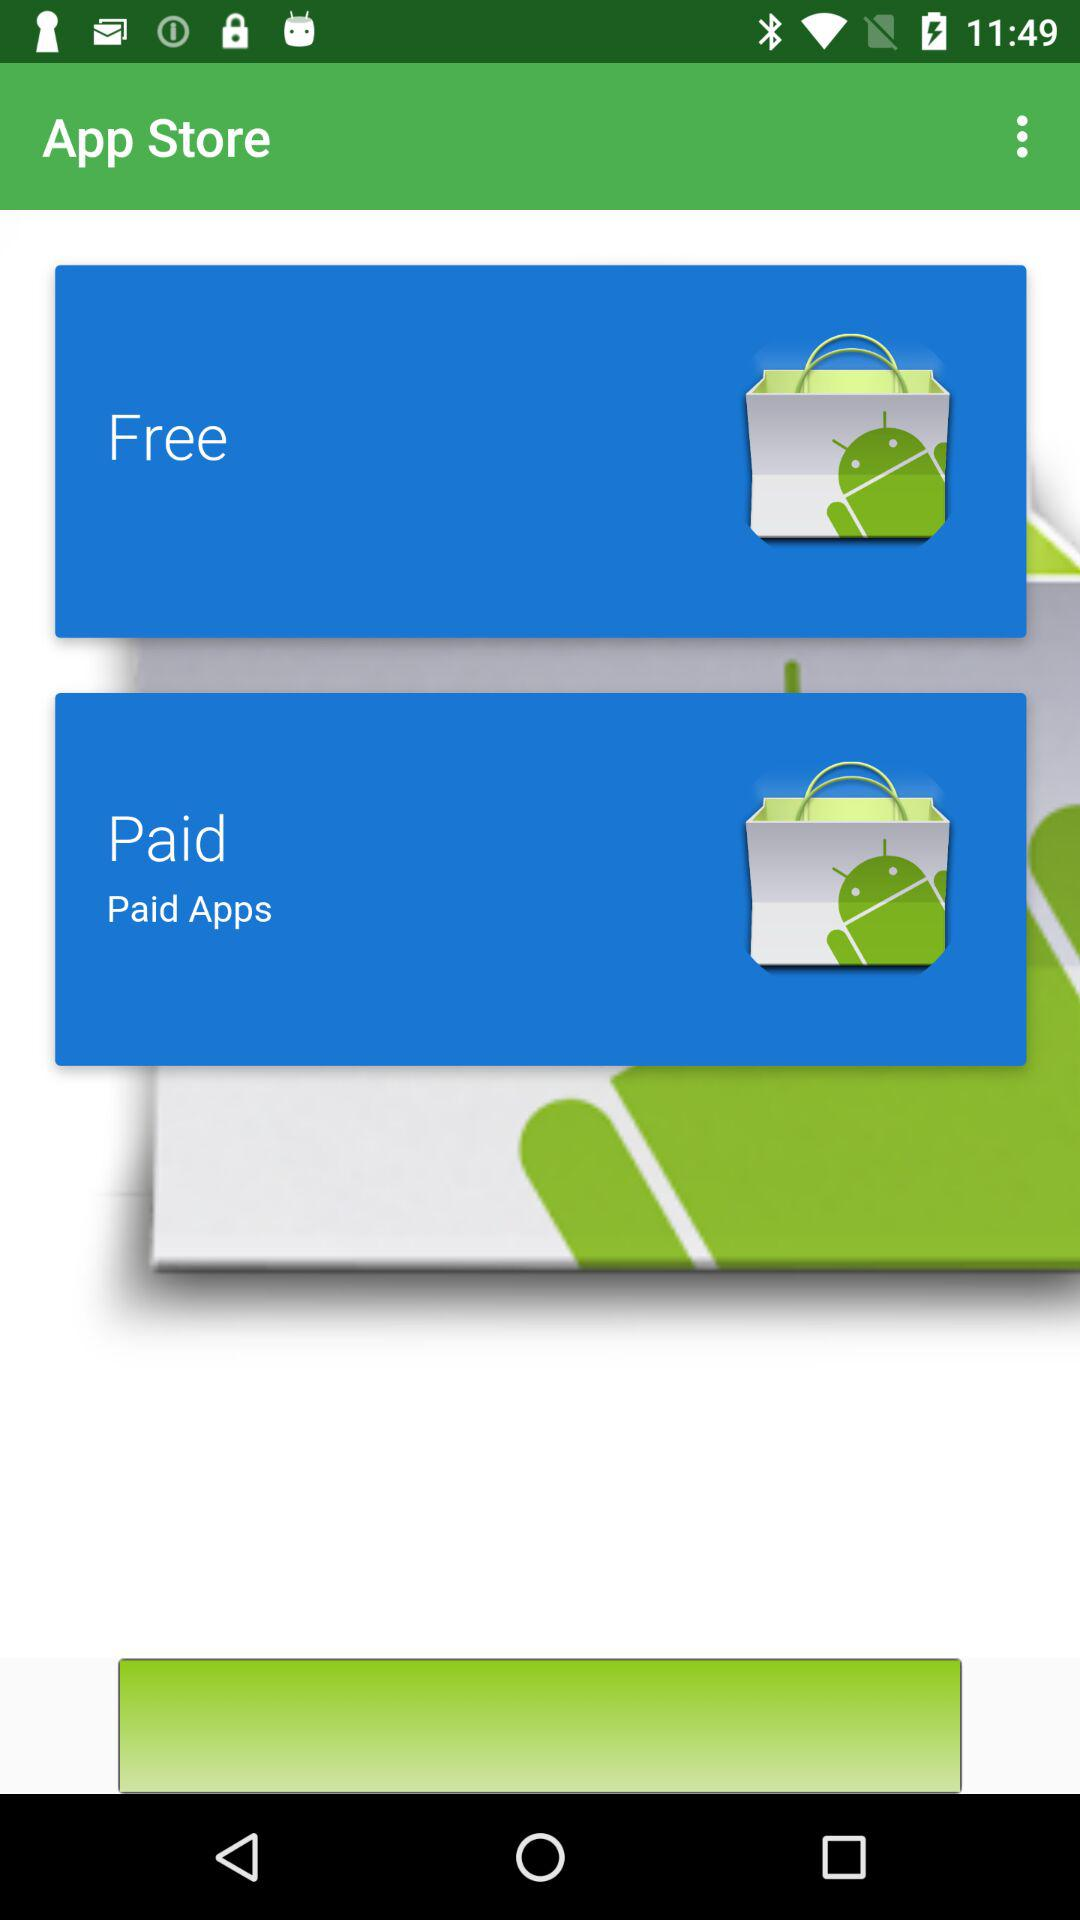Which options are available in the "App Store"? The available options are "Free" and "Paid". 